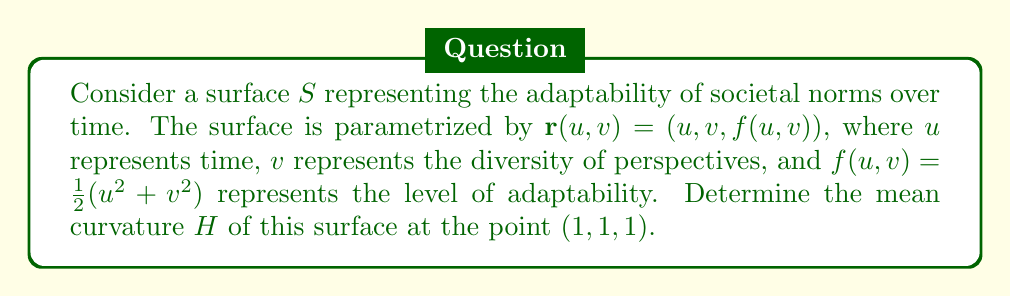Provide a solution to this math problem. To find the mean curvature, we'll follow these steps:

1) First, we need to calculate the partial derivatives:
   $\mathbf{r}_u = (1, 0, u)$
   $\mathbf{r}_v = (0, 1, v)$
   $\mathbf{r}_{uu} = (0, 0, 1)$
   $\mathbf{r}_{vv} = (0, 0, 1)$
   $\mathbf{r}_{uv} = (0, 0, 0)$

2) Next, we calculate the coefficients of the first fundamental form:
   $E = \mathbf{r}_u \cdot \mathbf{r}_u = 1 + u^2$
   $F = \mathbf{r}_u \cdot \mathbf{r}_v = uv$
   $G = \mathbf{r}_v \cdot \mathbf{r}_v = 1 + v^2$

3) We also need the unit normal vector:
   $\mathbf{N} = \frac{\mathbf{r}_u \times \mathbf{r}_v}{|\mathbf{r}_u \times \mathbf{r}_v|} = \frac{(-u, -v, 1)}{\sqrt{u^2 + v^2 + 1}}$

4) Now we calculate the coefficients of the second fundamental form:
   $e = \mathbf{r}_{uu} \cdot \mathbf{N} = \frac{1}{\sqrt{u^2 + v^2 + 1}}$
   $f = \mathbf{r}_{uv} \cdot \mathbf{N} = 0$
   $g = \mathbf{r}_{vv} \cdot \mathbf{N} = \frac{1}{\sqrt{u^2 + v^2 + 1}}$

5) The mean curvature is given by the formula:
   $$H = \frac{eG - 2fF + gE}{2(EG - F^2)}$$

6) Substituting the values at the point (1,1,1):
   $E = 2$, $F = 1$, $G = 2$
   $e = g = \frac{1}{\sqrt{3}}$, $f = 0$

7) Plugging these into the formula:
   $$H = \frac{\frac{1}{\sqrt{3}}(2) - 2(0)(1) + \frac{1}{\sqrt{3}}(2)}{2(2(2) - 1^2)} = \frac{2\sqrt{3}}{6} = \frac{\sqrt{3}}{3}$$

This value represents the average rate of change of the normal vector at the given point, indicating how quickly societal norms are adapting in relation to time and diversity of perspectives.
Answer: $\frac{\sqrt{3}}{3}$ 